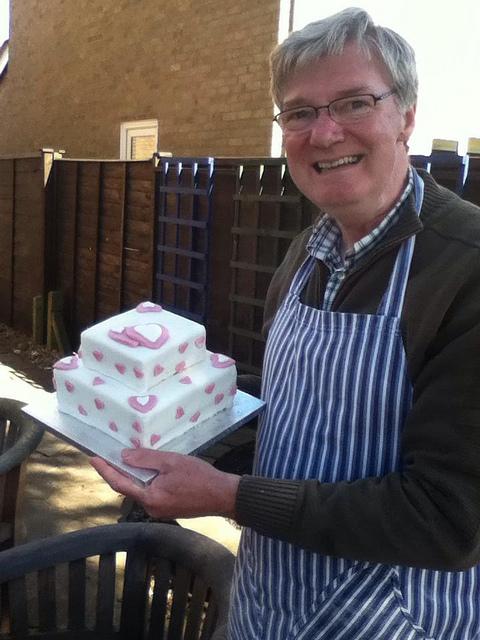What is blue and white?
Short answer required. Apron. How many tiers on the cake?
Short answer required. 2. Is this outside?
Be succinct. Yes. 